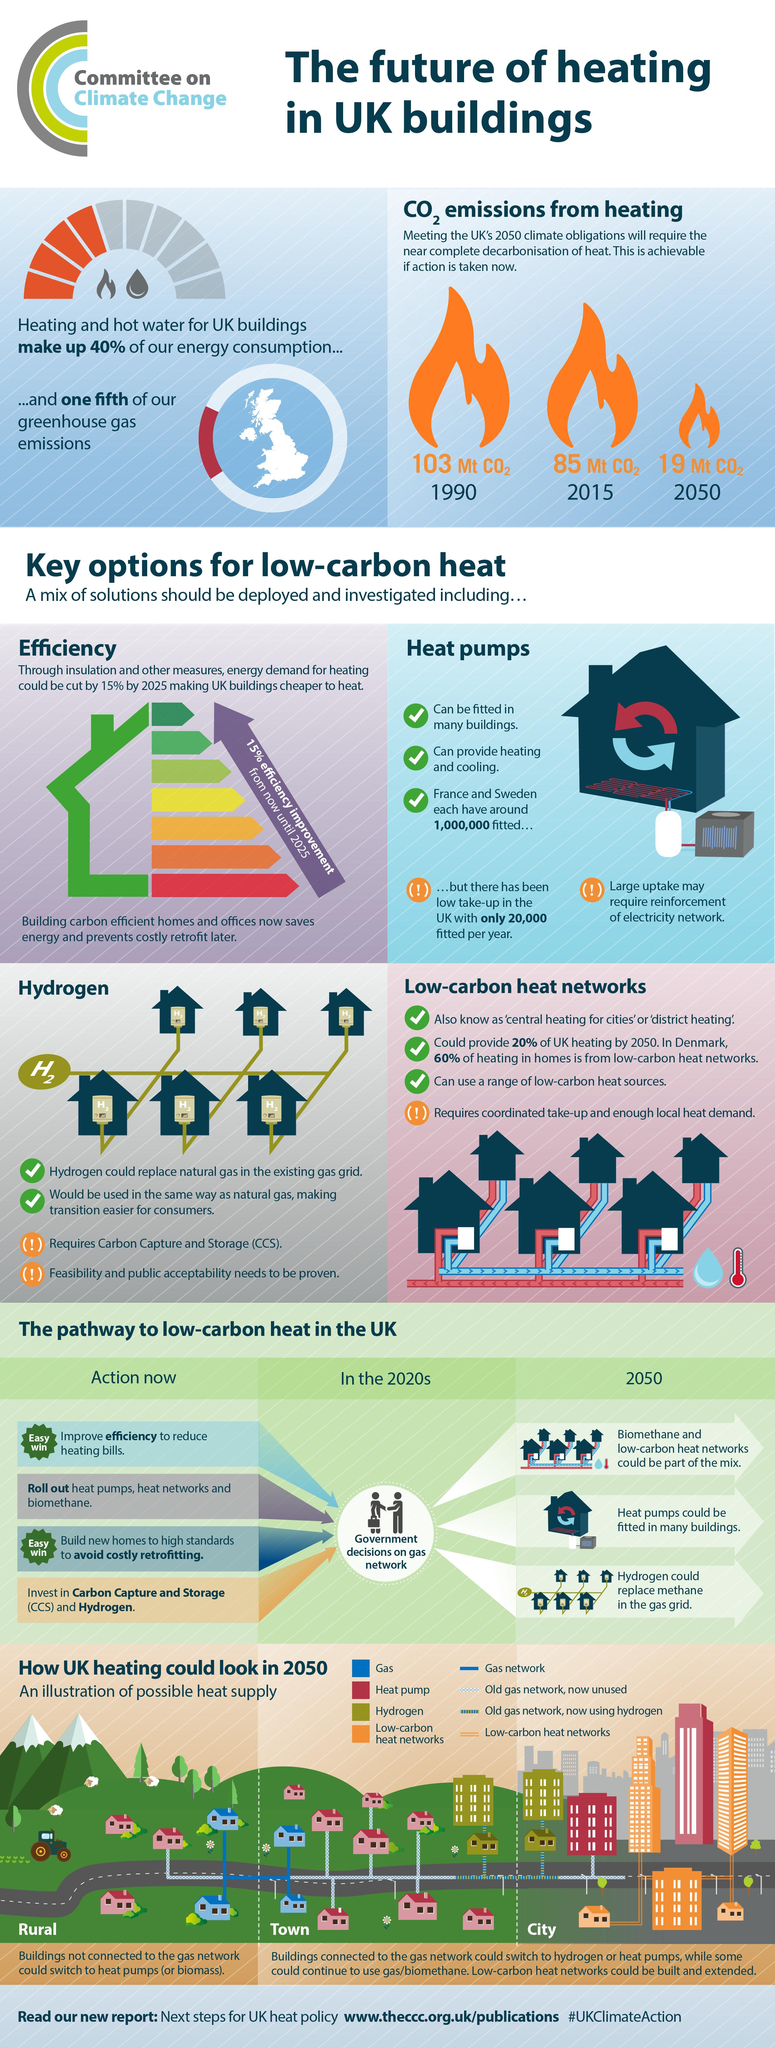Draw attention to some important aspects in this diagram. According to estimates, around 1,000,000 heat pumps have been installed in France. According to recent data, heating and hot water account for 20% of greenhouse gas emissions in the UK. 